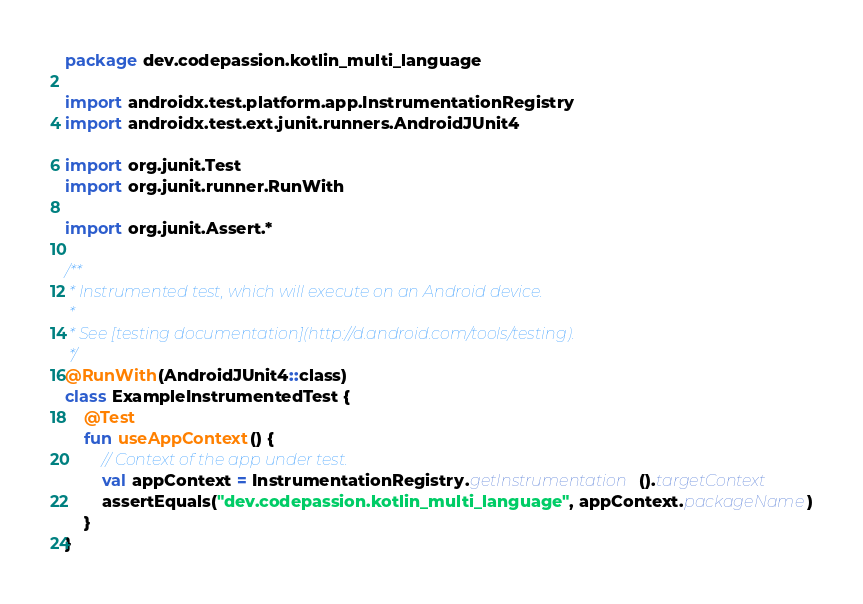<code> <loc_0><loc_0><loc_500><loc_500><_Kotlin_>package dev.codepassion.kotlin_multi_language

import androidx.test.platform.app.InstrumentationRegistry
import androidx.test.ext.junit.runners.AndroidJUnit4

import org.junit.Test
import org.junit.runner.RunWith

import org.junit.Assert.*

/**
 * Instrumented test, which will execute on an Android device.
 *
 * See [testing documentation](http://d.android.com/tools/testing).
 */
@RunWith(AndroidJUnit4::class)
class ExampleInstrumentedTest {
    @Test
    fun useAppContext() {
        // Context of the app under test.
        val appContext = InstrumentationRegistry.getInstrumentation().targetContext
        assertEquals("dev.codepassion.kotlin_multi_language", appContext.packageName)
    }
}
</code> 